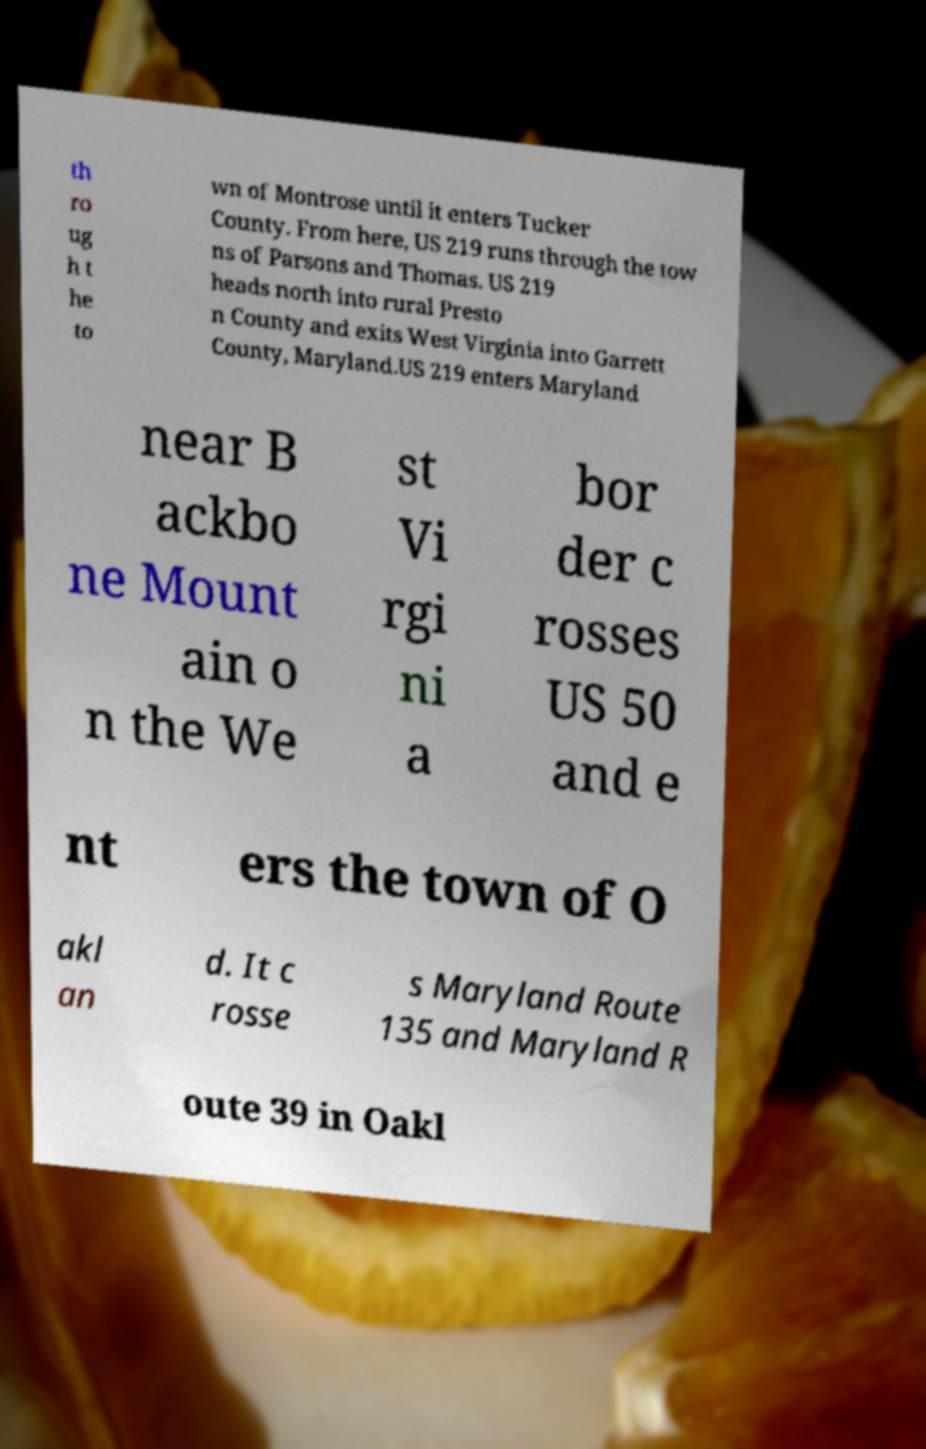Can you accurately transcribe the text from the provided image for me? th ro ug h t he to wn of Montrose until it enters Tucker County. From here, US 219 runs through the tow ns of Parsons and Thomas. US 219 heads north into rural Presto n County and exits West Virginia into Garrett County, Maryland.US 219 enters Maryland near B ackbo ne Mount ain o n the We st Vi rgi ni a bor der c rosses US 50 and e nt ers the town of O akl an d. It c rosse s Maryland Route 135 and Maryland R oute 39 in Oakl 